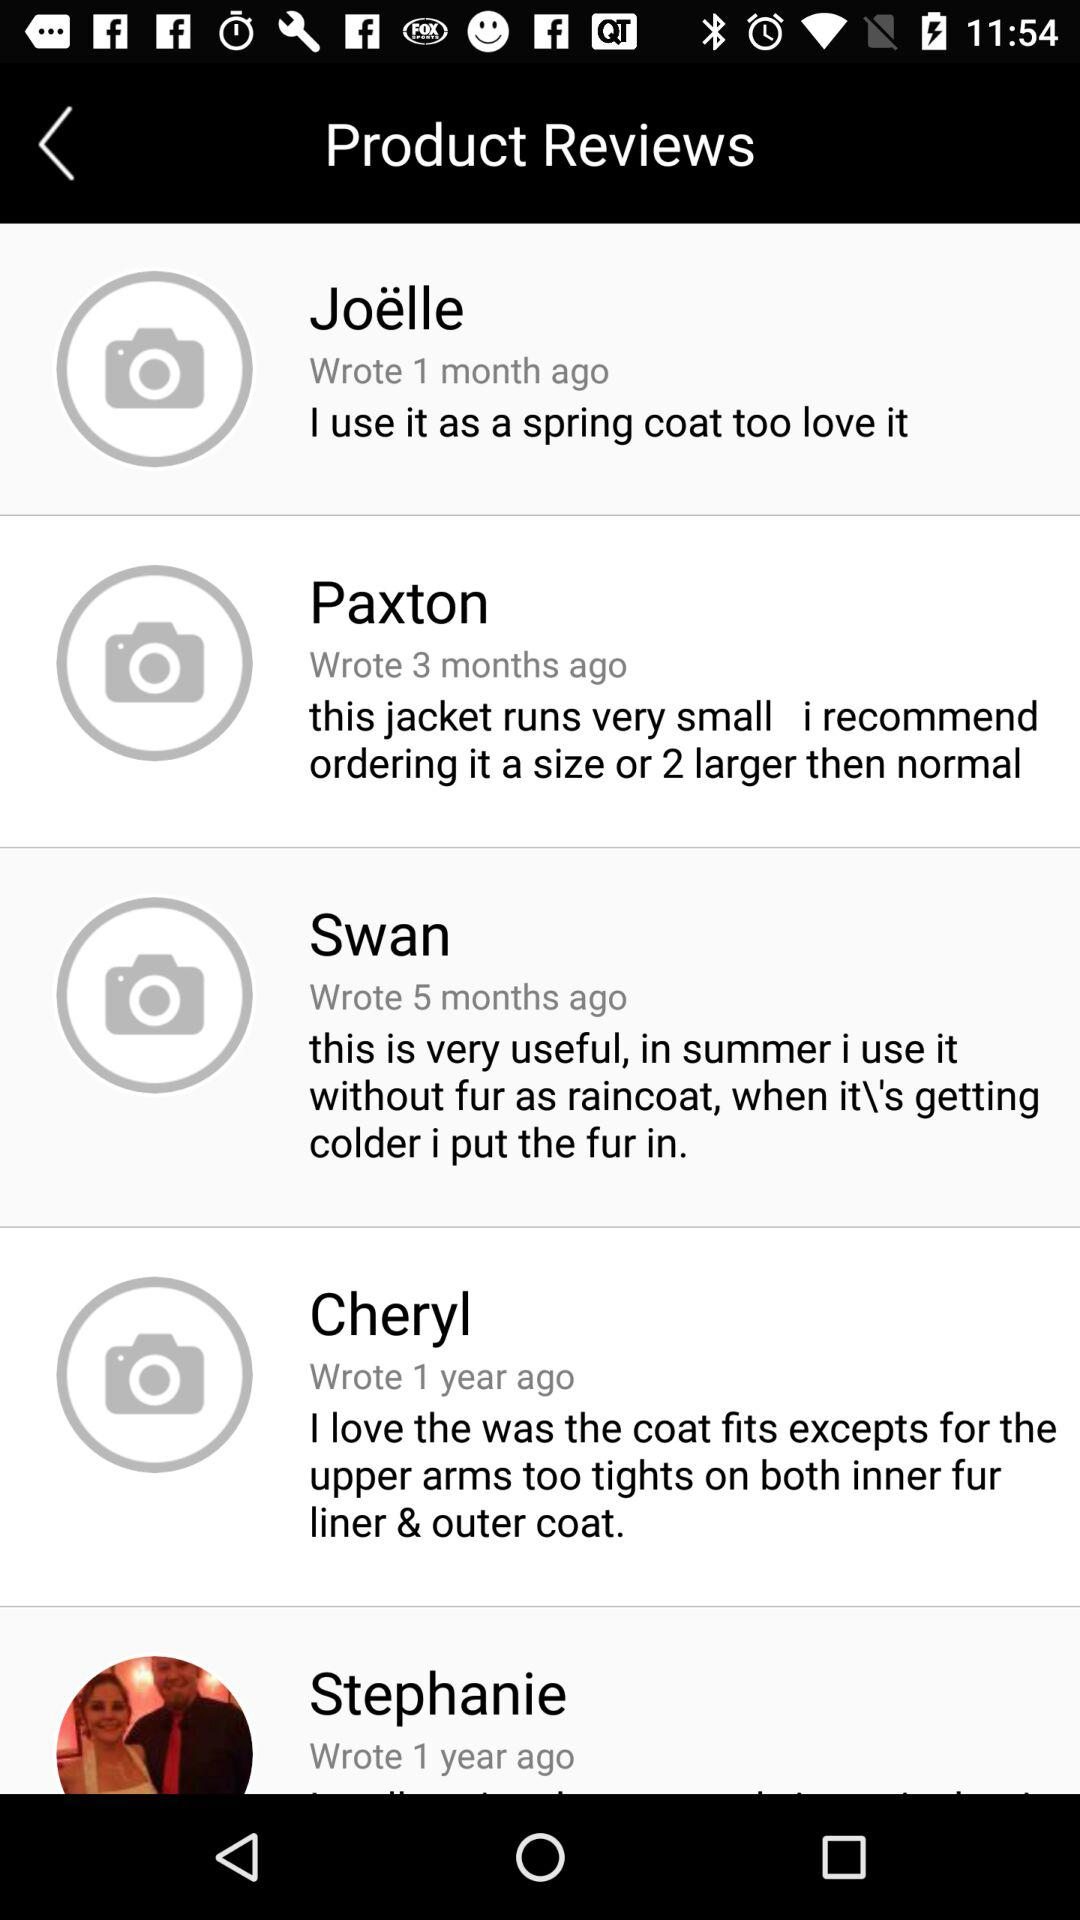What review did Cheryl had posted? The review posted by Cheryl was "I love the was the coat fits excepts for the upper arms too tight on both inner fur liner &outer coat". 